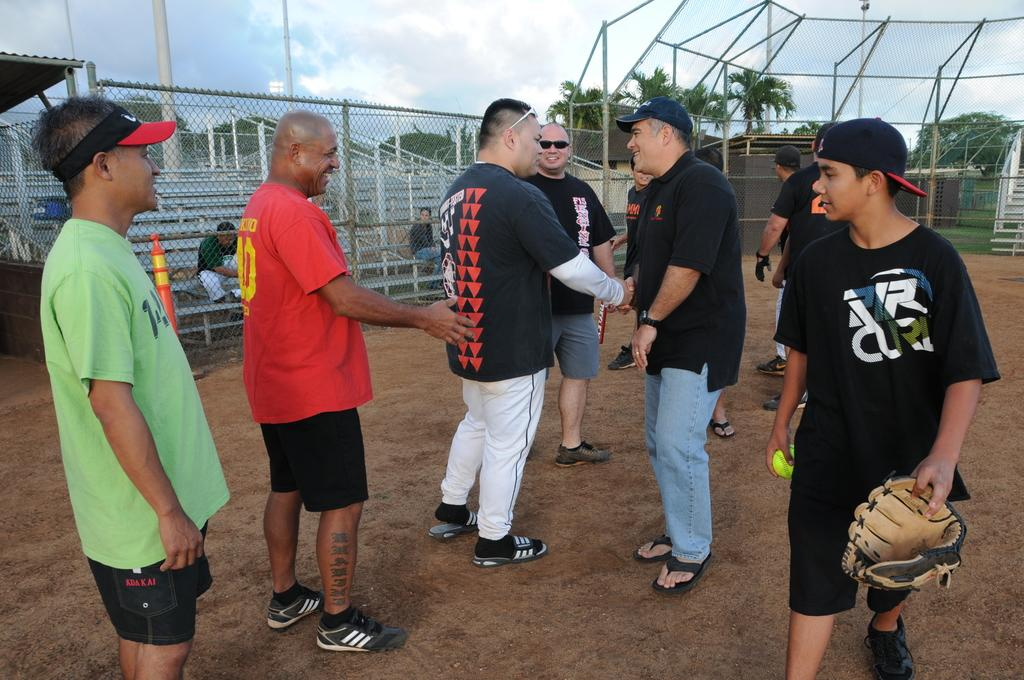<image>
Summarize the visual content of the image. a boy walking with the letter R on his shirt 